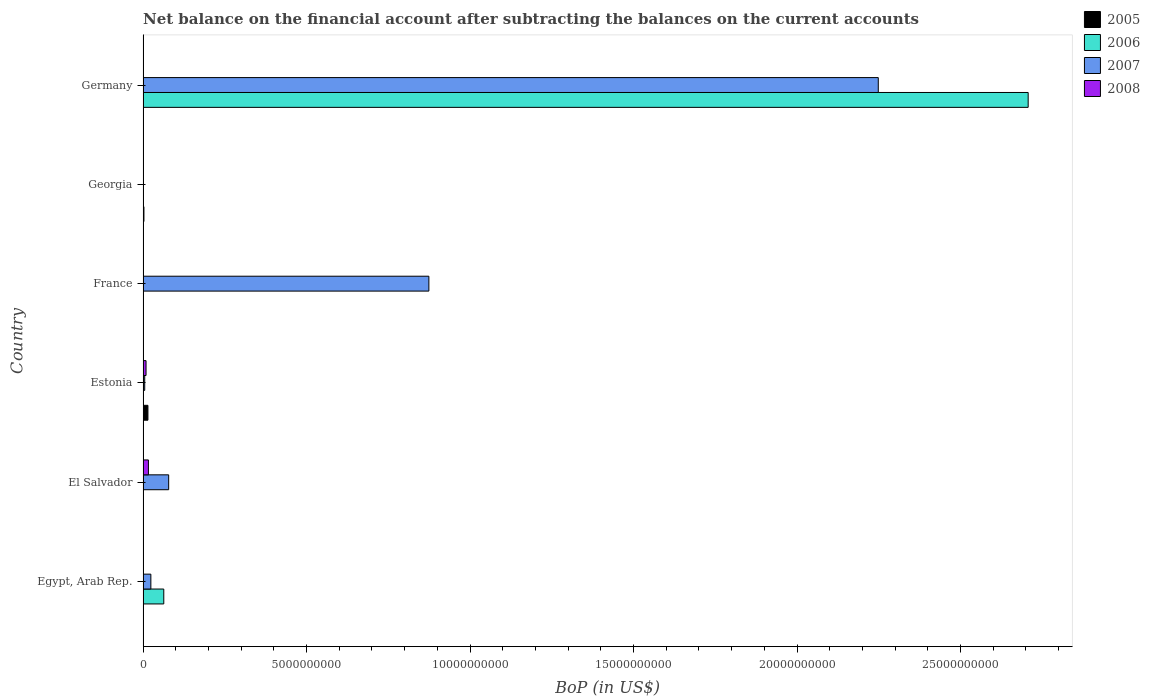How many different coloured bars are there?
Give a very brief answer. 4. How many bars are there on the 1st tick from the bottom?
Ensure brevity in your answer.  2. What is the label of the 4th group of bars from the top?
Offer a terse response. Estonia. In how many cases, is the number of bars for a given country not equal to the number of legend labels?
Give a very brief answer. 6. Across all countries, what is the maximum Balance of Payments in 2006?
Your response must be concise. 2.71e+1. What is the total Balance of Payments in 2005 in the graph?
Your answer should be very brief. 1.75e+08. What is the difference between the Balance of Payments in 2007 in El Salvador and that in Estonia?
Provide a succinct answer. 7.32e+08. What is the average Balance of Payments in 2005 per country?
Give a very brief answer. 2.92e+07. What is the difference between the Balance of Payments in 2008 and Balance of Payments in 2007 in Estonia?
Offer a terse response. 4.06e+07. In how many countries, is the Balance of Payments in 2007 greater than 23000000000 US$?
Make the answer very short. 0. Is the Balance of Payments in 2007 in El Salvador less than that in Estonia?
Keep it short and to the point. No. What is the difference between the highest and the second highest Balance of Payments in 2007?
Offer a terse response. 1.37e+1. What is the difference between the highest and the lowest Balance of Payments in 2007?
Make the answer very short. 2.25e+1. Are the values on the major ticks of X-axis written in scientific E-notation?
Your answer should be very brief. No. Does the graph contain any zero values?
Ensure brevity in your answer.  Yes. Does the graph contain grids?
Give a very brief answer. No. How many legend labels are there?
Give a very brief answer. 4. How are the legend labels stacked?
Ensure brevity in your answer.  Vertical. What is the title of the graph?
Make the answer very short. Net balance on the financial account after subtracting the balances on the current accounts. Does "2007" appear as one of the legend labels in the graph?
Your response must be concise. Yes. What is the label or title of the X-axis?
Your answer should be very brief. BoP (in US$). What is the label or title of the Y-axis?
Provide a succinct answer. Country. What is the BoP (in US$) in 2005 in Egypt, Arab Rep.?
Ensure brevity in your answer.  0. What is the BoP (in US$) of 2006 in Egypt, Arab Rep.?
Your answer should be very brief. 6.33e+08. What is the BoP (in US$) in 2007 in Egypt, Arab Rep.?
Make the answer very short. 2.39e+08. What is the BoP (in US$) of 2008 in Egypt, Arab Rep.?
Keep it short and to the point. 0. What is the BoP (in US$) of 2007 in El Salvador?
Make the answer very short. 7.83e+08. What is the BoP (in US$) in 2008 in El Salvador?
Give a very brief answer. 1.64e+08. What is the BoP (in US$) of 2005 in Estonia?
Your answer should be very brief. 1.49e+08. What is the BoP (in US$) of 2007 in Estonia?
Provide a succinct answer. 5.07e+07. What is the BoP (in US$) of 2008 in Estonia?
Offer a very short reply. 9.13e+07. What is the BoP (in US$) in 2005 in France?
Offer a very short reply. 0. What is the BoP (in US$) of 2006 in France?
Provide a short and direct response. 0. What is the BoP (in US$) of 2007 in France?
Ensure brevity in your answer.  8.74e+09. What is the BoP (in US$) in 2008 in France?
Give a very brief answer. 0. What is the BoP (in US$) in 2005 in Georgia?
Your answer should be very brief. 2.65e+07. What is the BoP (in US$) in 2007 in Georgia?
Give a very brief answer. 0. What is the BoP (in US$) of 2008 in Georgia?
Your response must be concise. 0. What is the BoP (in US$) of 2006 in Germany?
Your answer should be very brief. 2.71e+1. What is the BoP (in US$) in 2007 in Germany?
Make the answer very short. 2.25e+1. Across all countries, what is the maximum BoP (in US$) in 2005?
Your response must be concise. 1.49e+08. Across all countries, what is the maximum BoP (in US$) of 2006?
Offer a terse response. 2.71e+1. Across all countries, what is the maximum BoP (in US$) of 2007?
Keep it short and to the point. 2.25e+1. Across all countries, what is the maximum BoP (in US$) in 2008?
Provide a short and direct response. 1.64e+08. Across all countries, what is the minimum BoP (in US$) of 2006?
Ensure brevity in your answer.  0. Across all countries, what is the minimum BoP (in US$) in 2007?
Provide a short and direct response. 0. What is the total BoP (in US$) of 2005 in the graph?
Provide a succinct answer. 1.75e+08. What is the total BoP (in US$) of 2006 in the graph?
Offer a very short reply. 2.77e+1. What is the total BoP (in US$) in 2007 in the graph?
Give a very brief answer. 3.23e+1. What is the total BoP (in US$) in 2008 in the graph?
Ensure brevity in your answer.  2.55e+08. What is the difference between the BoP (in US$) of 2007 in Egypt, Arab Rep. and that in El Salvador?
Your answer should be very brief. -5.45e+08. What is the difference between the BoP (in US$) in 2007 in Egypt, Arab Rep. and that in Estonia?
Keep it short and to the point. 1.88e+08. What is the difference between the BoP (in US$) in 2007 in Egypt, Arab Rep. and that in France?
Keep it short and to the point. -8.50e+09. What is the difference between the BoP (in US$) of 2006 in Egypt, Arab Rep. and that in Germany?
Your response must be concise. -2.64e+1. What is the difference between the BoP (in US$) of 2007 in Egypt, Arab Rep. and that in Germany?
Your response must be concise. -2.22e+1. What is the difference between the BoP (in US$) of 2007 in El Salvador and that in Estonia?
Provide a succinct answer. 7.32e+08. What is the difference between the BoP (in US$) of 2008 in El Salvador and that in Estonia?
Make the answer very short. 7.27e+07. What is the difference between the BoP (in US$) of 2007 in El Salvador and that in France?
Ensure brevity in your answer.  -7.96e+09. What is the difference between the BoP (in US$) in 2007 in El Salvador and that in Germany?
Ensure brevity in your answer.  -2.17e+1. What is the difference between the BoP (in US$) of 2007 in Estonia and that in France?
Offer a terse response. -8.69e+09. What is the difference between the BoP (in US$) of 2005 in Estonia and that in Georgia?
Give a very brief answer. 1.22e+08. What is the difference between the BoP (in US$) in 2007 in Estonia and that in Germany?
Give a very brief answer. -2.24e+1. What is the difference between the BoP (in US$) of 2007 in France and that in Germany?
Give a very brief answer. -1.37e+1. What is the difference between the BoP (in US$) of 2006 in Egypt, Arab Rep. and the BoP (in US$) of 2007 in El Salvador?
Your answer should be compact. -1.50e+08. What is the difference between the BoP (in US$) in 2006 in Egypt, Arab Rep. and the BoP (in US$) in 2008 in El Salvador?
Your answer should be compact. 4.69e+08. What is the difference between the BoP (in US$) of 2007 in Egypt, Arab Rep. and the BoP (in US$) of 2008 in El Salvador?
Your answer should be very brief. 7.46e+07. What is the difference between the BoP (in US$) of 2006 in Egypt, Arab Rep. and the BoP (in US$) of 2007 in Estonia?
Provide a short and direct response. 5.83e+08. What is the difference between the BoP (in US$) in 2006 in Egypt, Arab Rep. and the BoP (in US$) in 2008 in Estonia?
Keep it short and to the point. 5.42e+08. What is the difference between the BoP (in US$) in 2007 in Egypt, Arab Rep. and the BoP (in US$) in 2008 in Estonia?
Provide a short and direct response. 1.47e+08. What is the difference between the BoP (in US$) of 2006 in Egypt, Arab Rep. and the BoP (in US$) of 2007 in France?
Your response must be concise. -8.11e+09. What is the difference between the BoP (in US$) of 2006 in Egypt, Arab Rep. and the BoP (in US$) of 2007 in Germany?
Give a very brief answer. -2.19e+1. What is the difference between the BoP (in US$) in 2007 in El Salvador and the BoP (in US$) in 2008 in Estonia?
Ensure brevity in your answer.  6.92e+08. What is the difference between the BoP (in US$) of 2005 in Estonia and the BoP (in US$) of 2007 in France?
Offer a very short reply. -8.59e+09. What is the difference between the BoP (in US$) of 2005 in Estonia and the BoP (in US$) of 2006 in Germany?
Give a very brief answer. -2.69e+1. What is the difference between the BoP (in US$) in 2005 in Estonia and the BoP (in US$) in 2007 in Germany?
Offer a terse response. -2.23e+1. What is the difference between the BoP (in US$) of 2005 in Georgia and the BoP (in US$) of 2006 in Germany?
Provide a succinct answer. -2.70e+1. What is the difference between the BoP (in US$) of 2005 in Georgia and the BoP (in US$) of 2007 in Germany?
Offer a terse response. -2.25e+1. What is the average BoP (in US$) of 2005 per country?
Your answer should be very brief. 2.92e+07. What is the average BoP (in US$) of 2006 per country?
Give a very brief answer. 4.62e+09. What is the average BoP (in US$) of 2007 per country?
Give a very brief answer. 5.38e+09. What is the average BoP (in US$) in 2008 per country?
Provide a succinct answer. 4.26e+07. What is the difference between the BoP (in US$) of 2006 and BoP (in US$) of 2007 in Egypt, Arab Rep.?
Your answer should be compact. 3.95e+08. What is the difference between the BoP (in US$) of 2007 and BoP (in US$) of 2008 in El Salvador?
Offer a terse response. 6.19e+08. What is the difference between the BoP (in US$) of 2005 and BoP (in US$) of 2007 in Estonia?
Give a very brief answer. 9.81e+07. What is the difference between the BoP (in US$) of 2005 and BoP (in US$) of 2008 in Estonia?
Your answer should be very brief. 5.75e+07. What is the difference between the BoP (in US$) of 2007 and BoP (in US$) of 2008 in Estonia?
Offer a terse response. -4.06e+07. What is the difference between the BoP (in US$) of 2006 and BoP (in US$) of 2007 in Germany?
Make the answer very short. 4.58e+09. What is the ratio of the BoP (in US$) of 2007 in Egypt, Arab Rep. to that in El Salvador?
Make the answer very short. 0.3. What is the ratio of the BoP (in US$) of 2007 in Egypt, Arab Rep. to that in Estonia?
Provide a short and direct response. 4.7. What is the ratio of the BoP (in US$) of 2007 in Egypt, Arab Rep. to that in France?
Offer a terse response. 0.03. What is the ratio of the BoP (in US$) in 2006 in Egypt, Arab Rep. to that in Germany?
Give a very brief answer. 0.02. What is the ratio of the BoP (in US$) of 2007 in Egypt, Arab Rep. to that in Germany?
Your response must be concise. 0.01. What is the ratio of the BoP (in US$) in 2007 in El Salvador to that in Estonia?
Your answer should be very brief. 15.44. What is the ratio of the BoP (in US$) of 2008 in El Salvador to that in Estonia?
Offer a terse response. 1.8. What is the ratio of the BoP (in US$) of 2007 in El Salvador to that in France?
Offer a terse response. 0.09. What is the ratio of the BoP (in US$) of 2007 in El Salvador to that in Germany?
Ensure brevity in your answer.  0.03. What is the ratio of the BoP (in US$) in 2007 in Estonia to that in France?
Keep it short and to the point. 0.01. What is the ratio of the BoP (in US$) in 2005 in Estonia to that in Georgia?
Make the answer very short. 5.61. What is the ratio of the BoP (in US$) of 2007 in Estonia to that in Germany?
Give a very brief answer. 0. What is the ratio of the BoP (in US$) of 2007 in France to that in Germany?
Provide a short and direct response. 0.39. What is the difference between the highest and the second highest BoP (in US$) of 2007?
Keep it short and to the point. 1.37e+1. What is the difference between the highest and the lowest BoP (in US$) in 2005?
Your response must be concise. 1.49e+08. What is the difference between the highest and the lowest BoP (in US$) of 2006?
Ensure brevity in your answer.  2.71e+1. What is the difference between the highest and the lowest BoP (in US$) in 2007?
Provide a succinct answer. 2.25e+1. What is the difference between the highest and the lowest BoP (in US$) of 2008?
Your answer should be compact. 1.64e+08. 